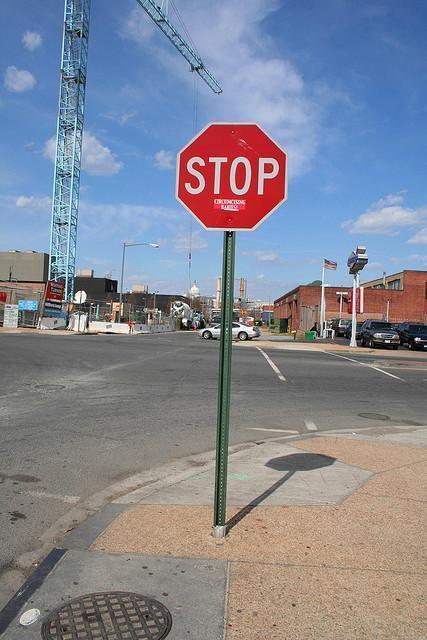How many yellow umbrellas are there?
Give a very brief answer. 0. 